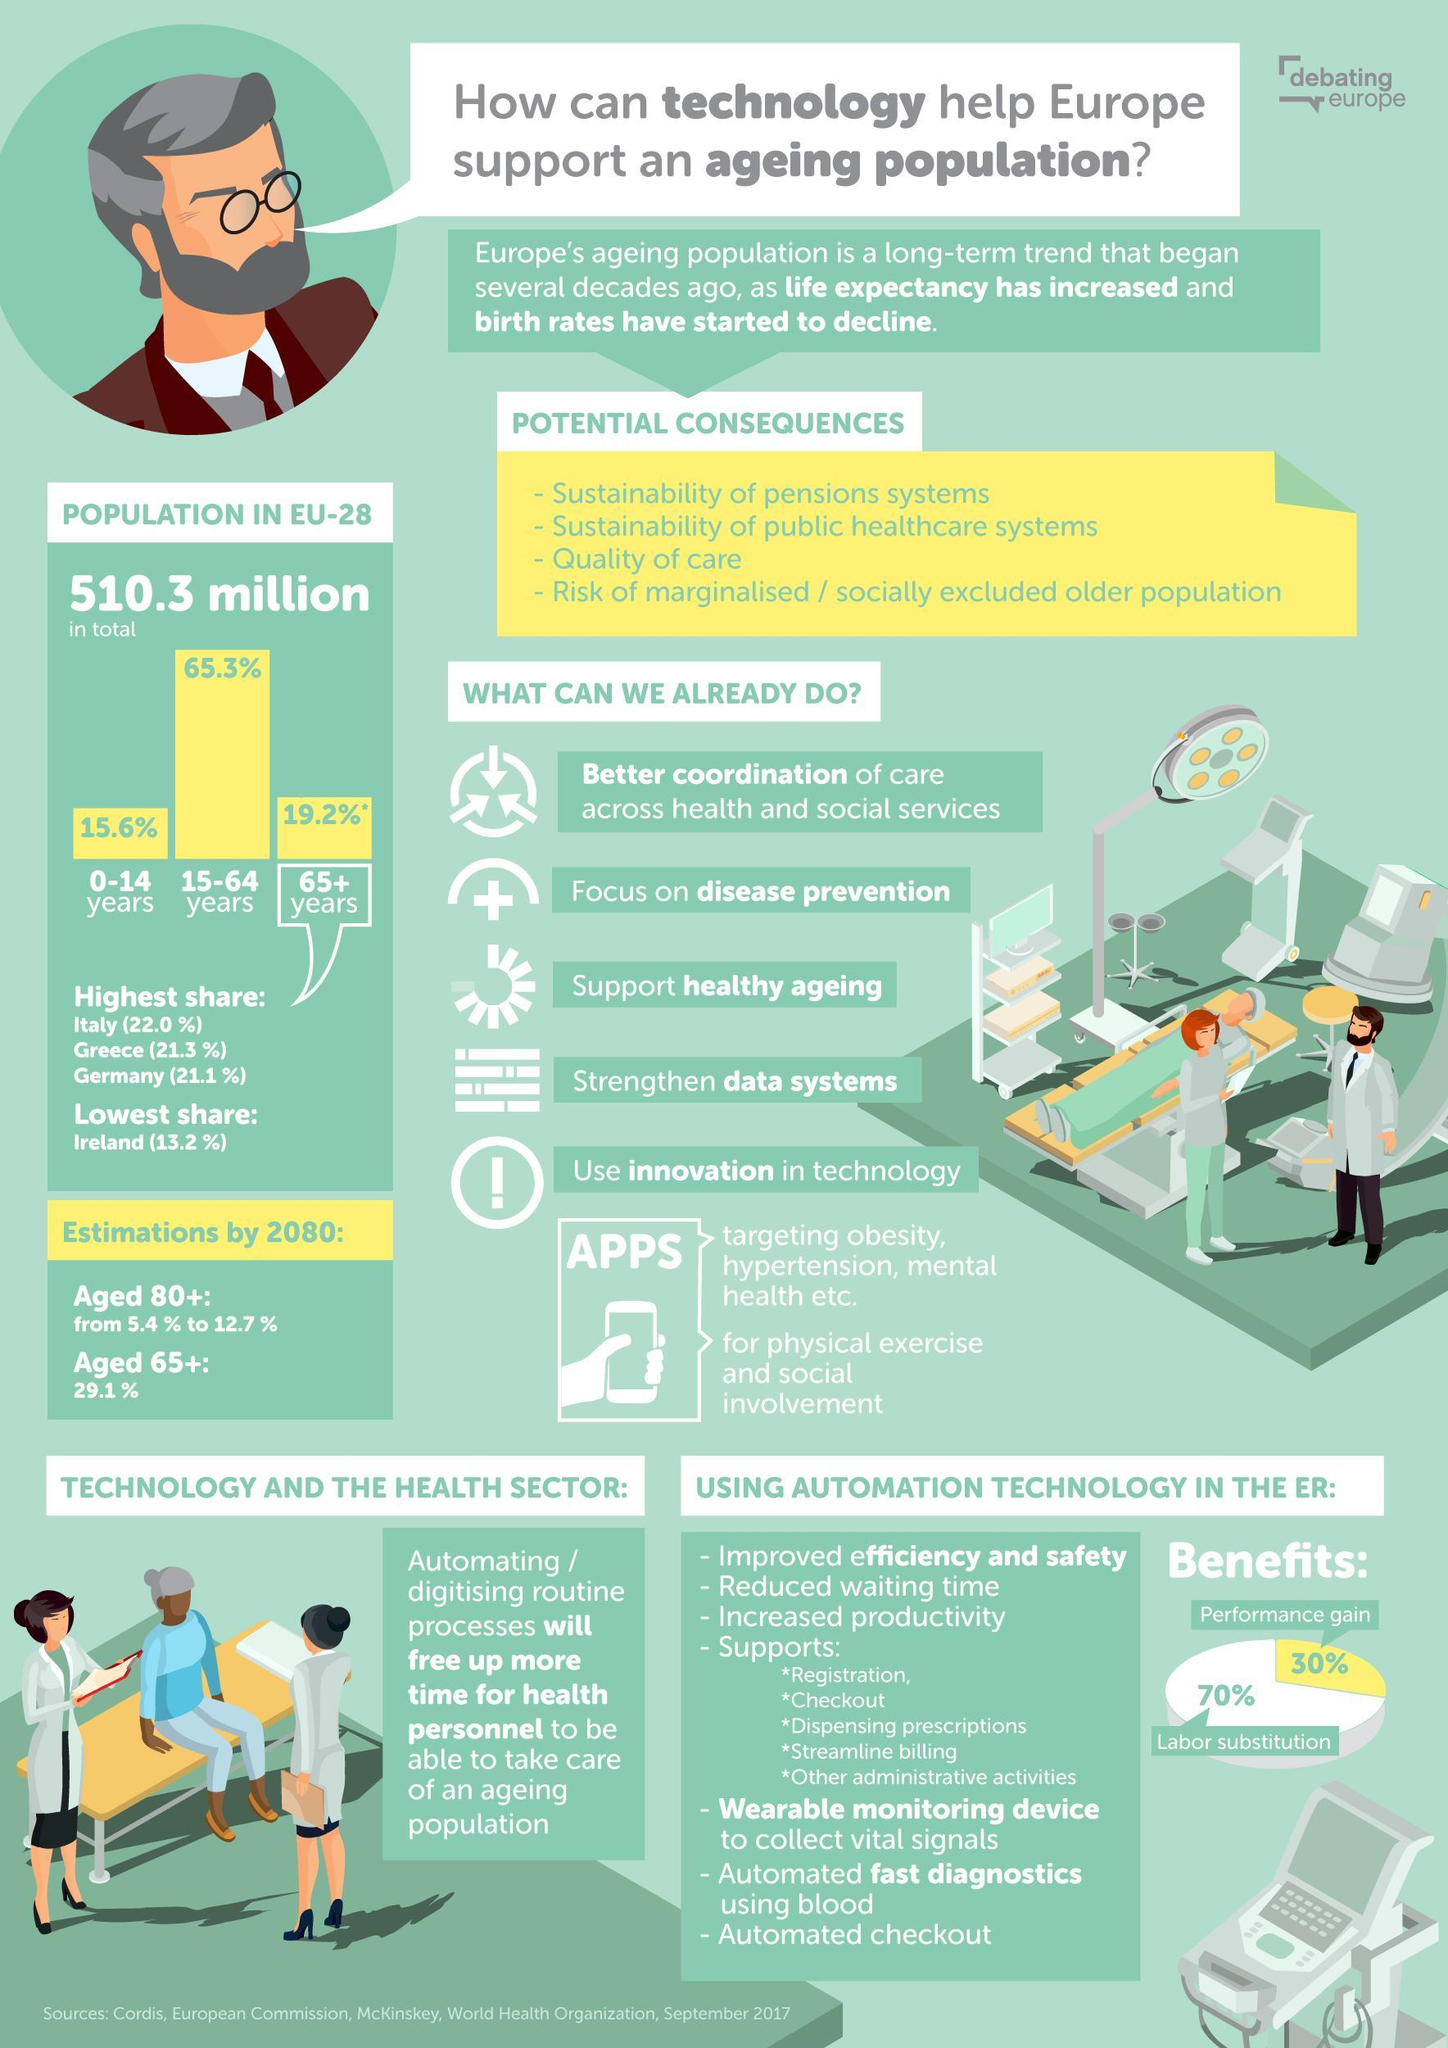How many points under the heading "Potential Consequences"?
Answer the question with a short phrase. 4 Which has the highest share-performance gain, Labor substitution? Labor substitution 